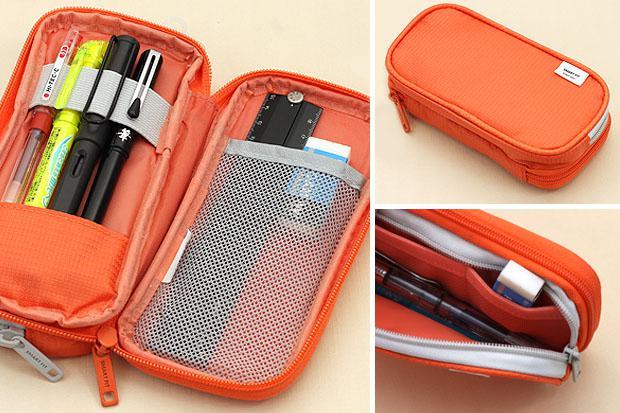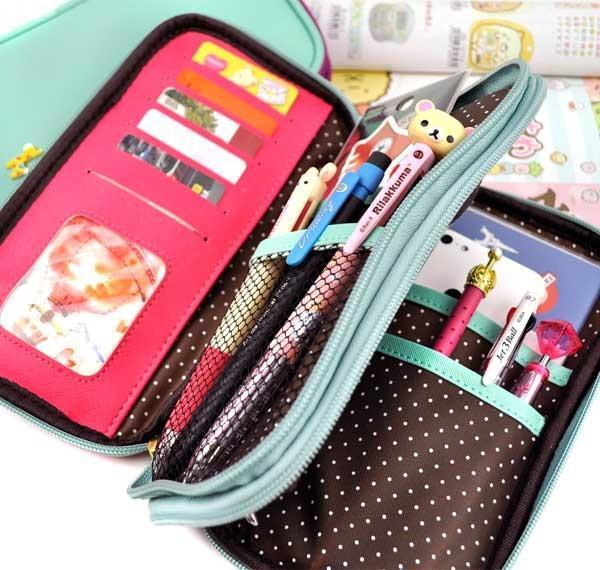The first image is the image on the left, the second image is the image on the right. For the images shown, is this caption "The pencil case in the left image share the same shape and size." true? Answer yes or no. No. The first image is the image on the left, the second image is the image on the right. Evaluate the accuracy of this statement regarding the images: "Each image contains an open turquoise blue pencil box.". Is it true? Answer yes or no. No. 